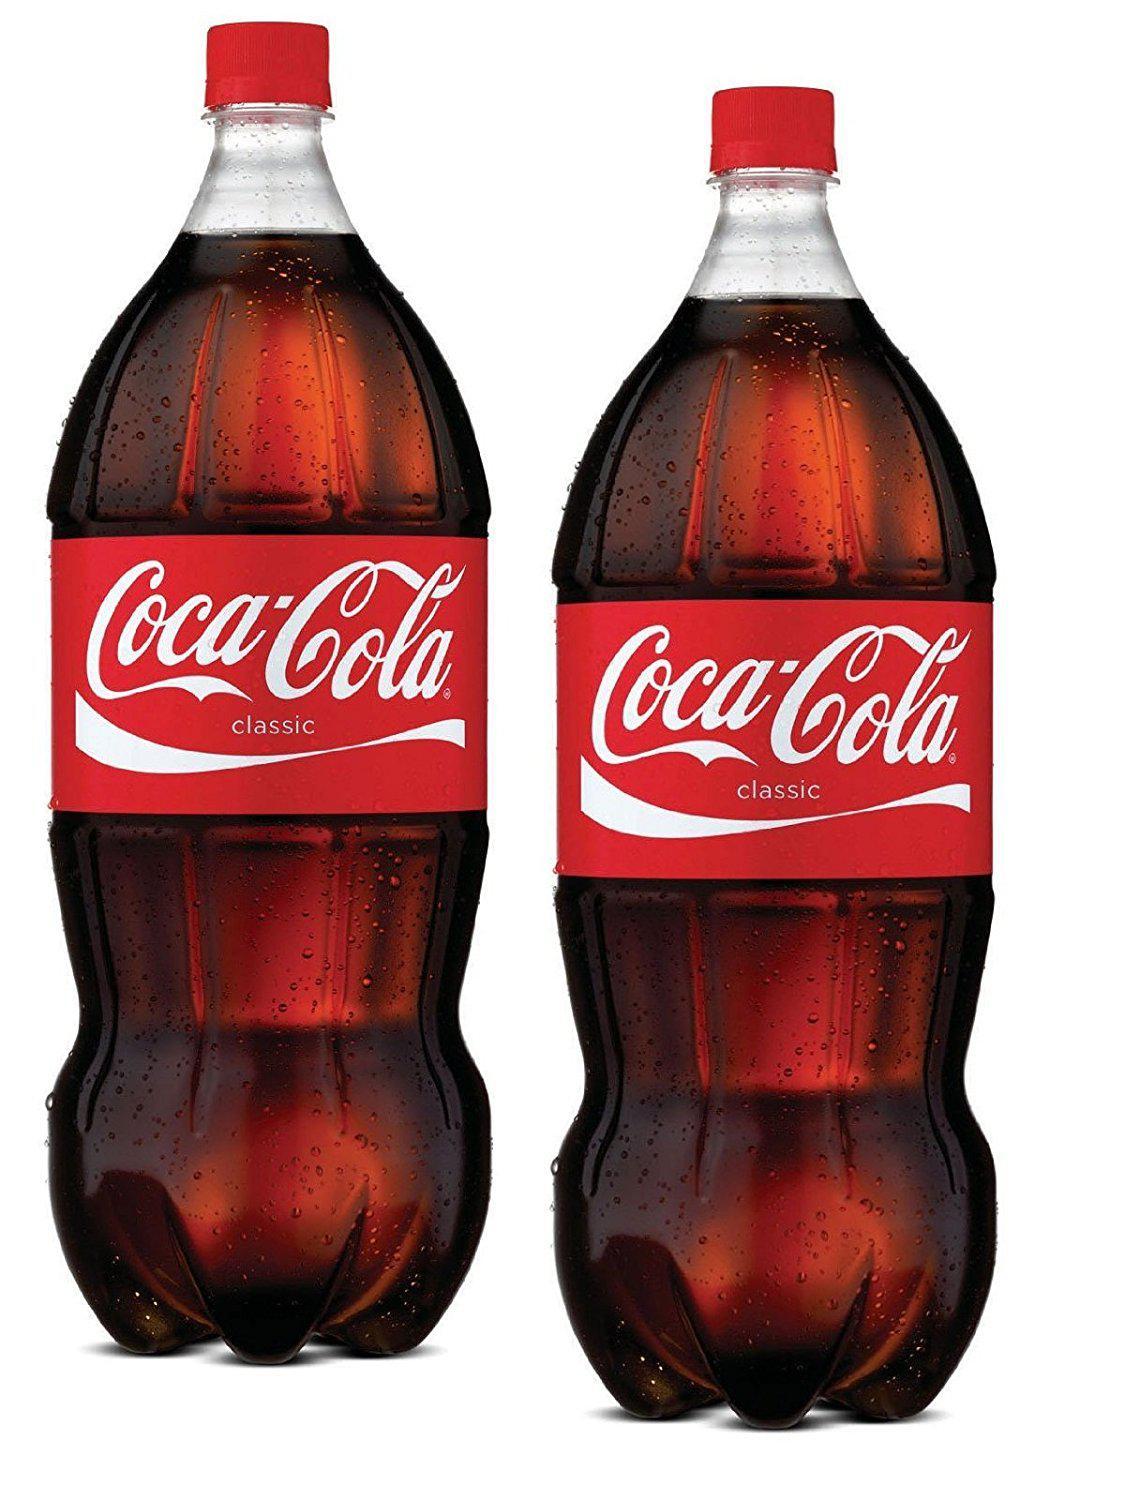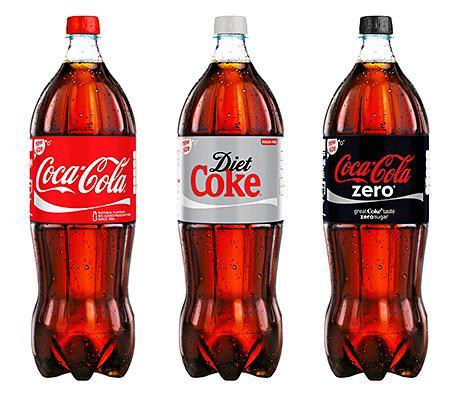The first image is the image on the left, the second image is the image on the right. For the images displayed, is the sentence "There are an odd number of sodas." factually correct? Answer yes or no. Yes. The first image is the image on the left, the second image is the image on the right. For the images shown, is this caption "There are at most six bottles in the image pair." true? Answer yes or no. Yes. 